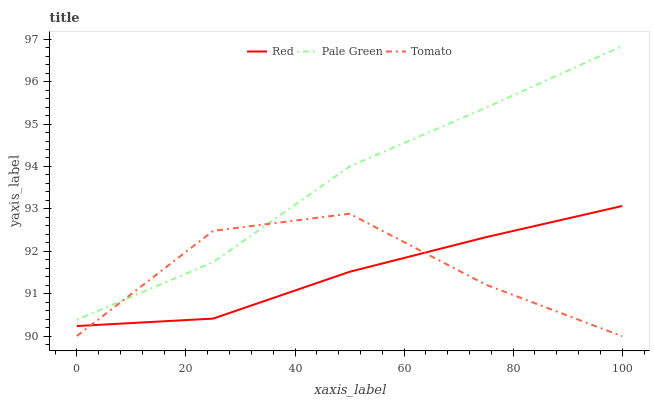Does Pale Green have the minimum area under the curve?
Answer yes or no. No. Does Red have the maximum area under the curve?
Answer yes or no. No. Is Pale Green the smoothest?
Answer yes or no. No. Is Pale Green the roughest?
Answer yes or no. No. Does Red have the lowest value?
Answer yes or no. No. Does Red have the highest value?
Answer yes or no. No. Is Red less than Pale Green?
Answer yes or no. Yes. Is Pale Green greater than Red?
Answer yes or no. Yes. Does Red intersect Pale Green?
Answer yes or no. No. 